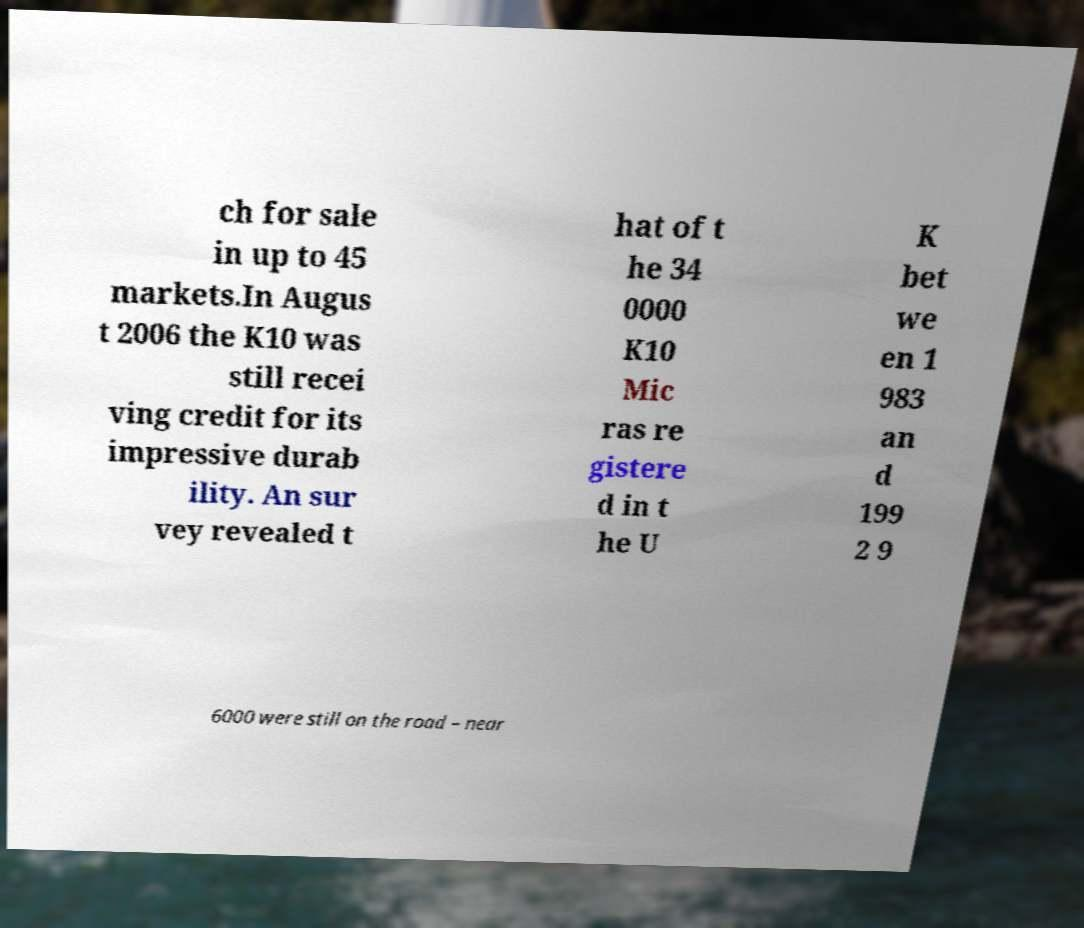What messages or text are displayed in this image? I need them in a readable, typed format. ch for sale in up to 45 markets.In Augus t 2006 the K10 was still recei ving credit for its impressive durab ility. An sur vey revealed t hat of t he 34 0000 K10 Mic ras re gistere d in t he U K bet we en 1 983 an d 199 2 9 6000 were still on the road – near 